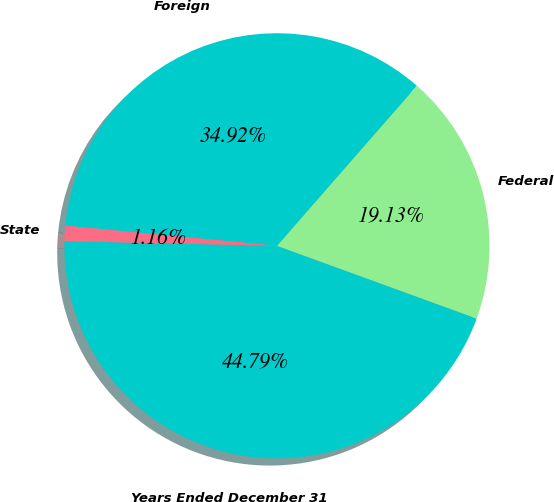Convert chart to OTSL. <chart><loc_0><loc_0><loc_500><loc_500><pie_chart><fcel>Years Ended December 31<fcel>Federal<fcel>Foreign<fcel>State<nl><fcel>44.79%<fcel>19.13%<fcel>34.92%<fcel>1.16%<nl></chart> 